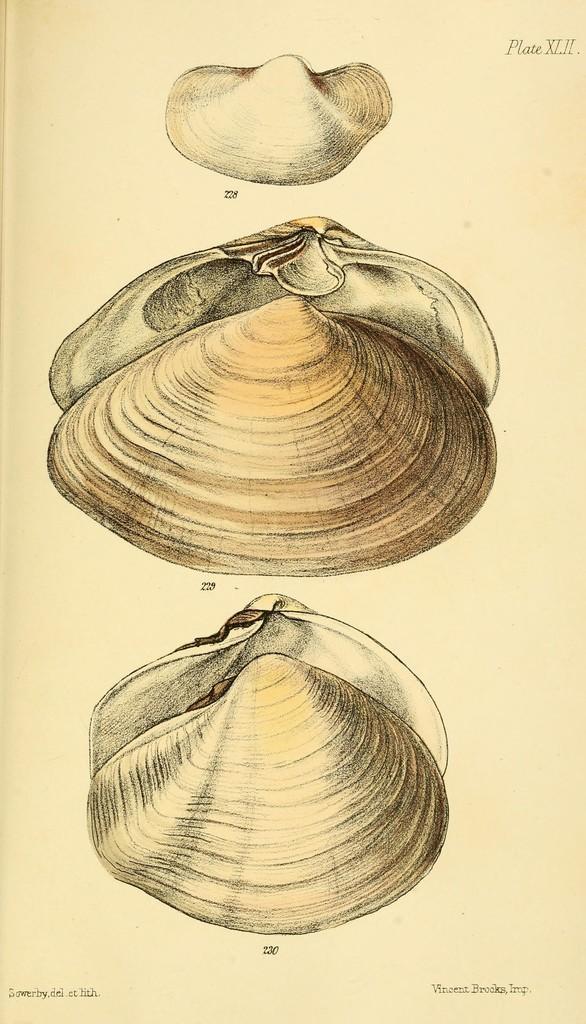Can you describe this image briefly? We can see pictures on shell on a paper and at the top and bottom there are texts written on the paper. 